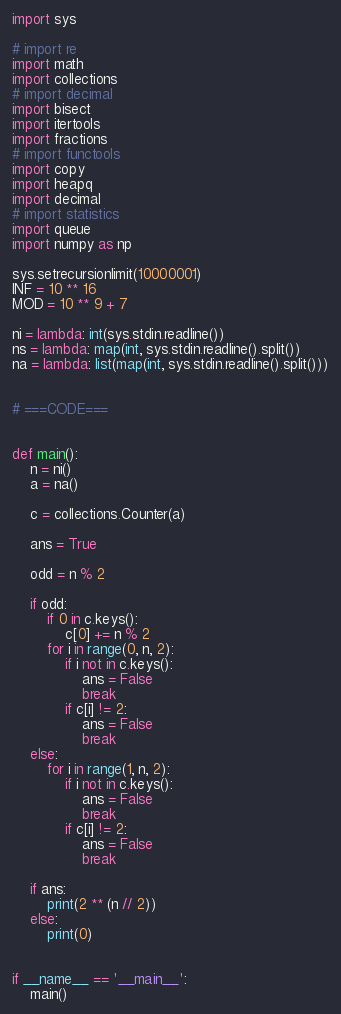<code> <loc_0><loc_0><loc_500><loc_500><_Python_>import sys

# import re
import math
import collections
# import decimal
import bisect
import itertools
import fractions
# import functools
import copy
import heapq
import decimal
# import statistics
import queue
import numpy as np

sys.setrecursionlimit(10000001)
INF = 10 ** 16
MOD = 10 ** 9 + 7

ni = lambda: int(sys.stdin.readline())
ns = lambda: map(int, sys.stdin.readline().split())
na = lambda: list(map(int, sys.stdin.readline().split()))


# ===CODE===


def main():
    n = ni()
    a = na()

    c = collections.Counter(a)

    ans = True

    odd = n % 2

    if odd:
        if 0 in c.keys():
            c[0] += n % 2
        for i in range(0, n, 2):
            if i not in c.keys():
                ans = False
                break
            if c[i] != 2:
                ans = False
                break
    else:
        for i in range(1, n, 2):
            if i not in c.keys():
                ans = False
                break
            if c[i] != 2:
                ans = False
                break

    if ans:
        print(2 ** (n // 2))
    else:
        print(0)


if __name__ == '__main__':
    main()
</code> 